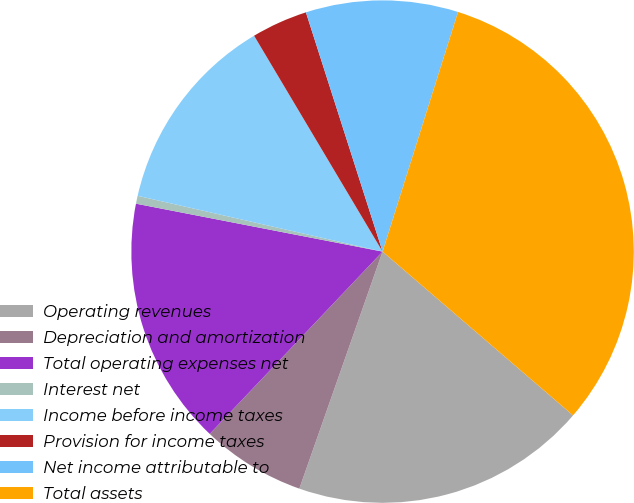Convert chart to OTSL. <chart><loc_0><loc_0><loc_500><loc_500><pie_chart><fcel>Operating revenues<fcel>Depreciation and amortization<fcel>Total operating expenses net<fcel>Interest net<fcel>Income before income taxes<fcel>Provision for income taxes<fcel>Net income attributable to<fcel>Total assets<nl><fcel>19.07%<fcel>6.7%<fcel>15.98%<fcel>0.51%<fcel>12.89%<fcel>3.61%<fcel>9.79%<fcel>31.45%<nl></chart> 